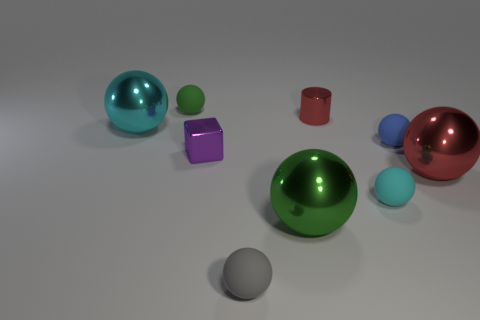There is another green thing that is the same shape as the big green object; what size is it?
Give a very brief answer. Small. Is the shape of the large metal thing left of the green rubber object the same as  the small blue rubber thing?
Provide a short and direct response. Yes. There is a cyan thing right of the ball that is left of the tiny green object; what shape is it?
Ensure brevity in your answer.  Sphere. Is there anything else that has the same shape as the cyan metal thing?
Your response must be concise. Yes. Is the color of the cylinder the same as the big ball that is to the right of the small cylinder?
Provide a short and direct response. Yes. What shape is the thing that is both left of the large green metallic thing and in front of the small cyan sphere?
Your response must be concise. Sphere. Are there fewer small red cylinders than red matte things?
Ensure brevity in your answer.  No. Are there any purple shiny things?
Make the answer very short. Yes. What number of other objects are there of the same size as the blue thing?
Your answer should be very brief. 5. Do the cube and the cyan thing left of the tiny red shiny object have the same material?
Provide a short and direct response. Yes. 